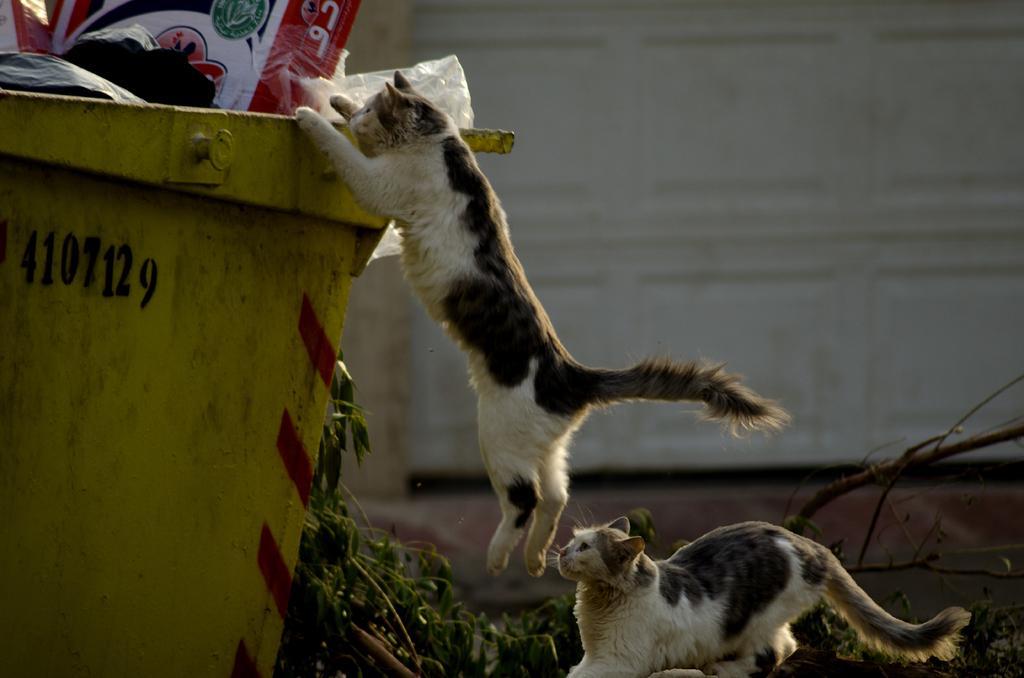Can you describe this image briefly? In this image there are two cats, one is jumping into the dustbin, beside the dustbin there are leaves of a tree. In the background there is the wall. 